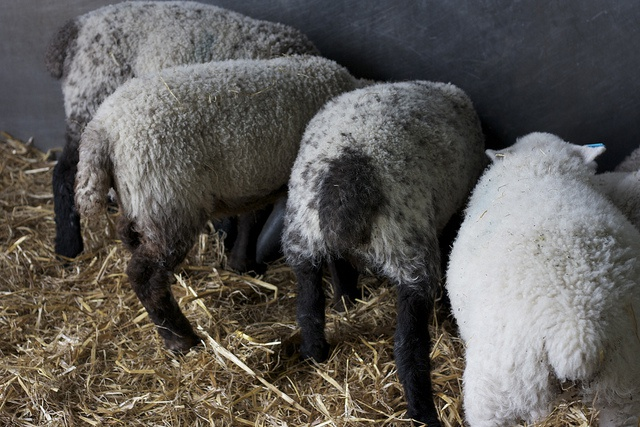Describe the objects in this image and their specific colors. I can see sheep in gray, lightgray, darkgray, and black tones, sheep in gray, black, and darkgray tones, sheep in gray, black, and darkgray tones, and sheep in gray, darkgray, and black tones in this image. 